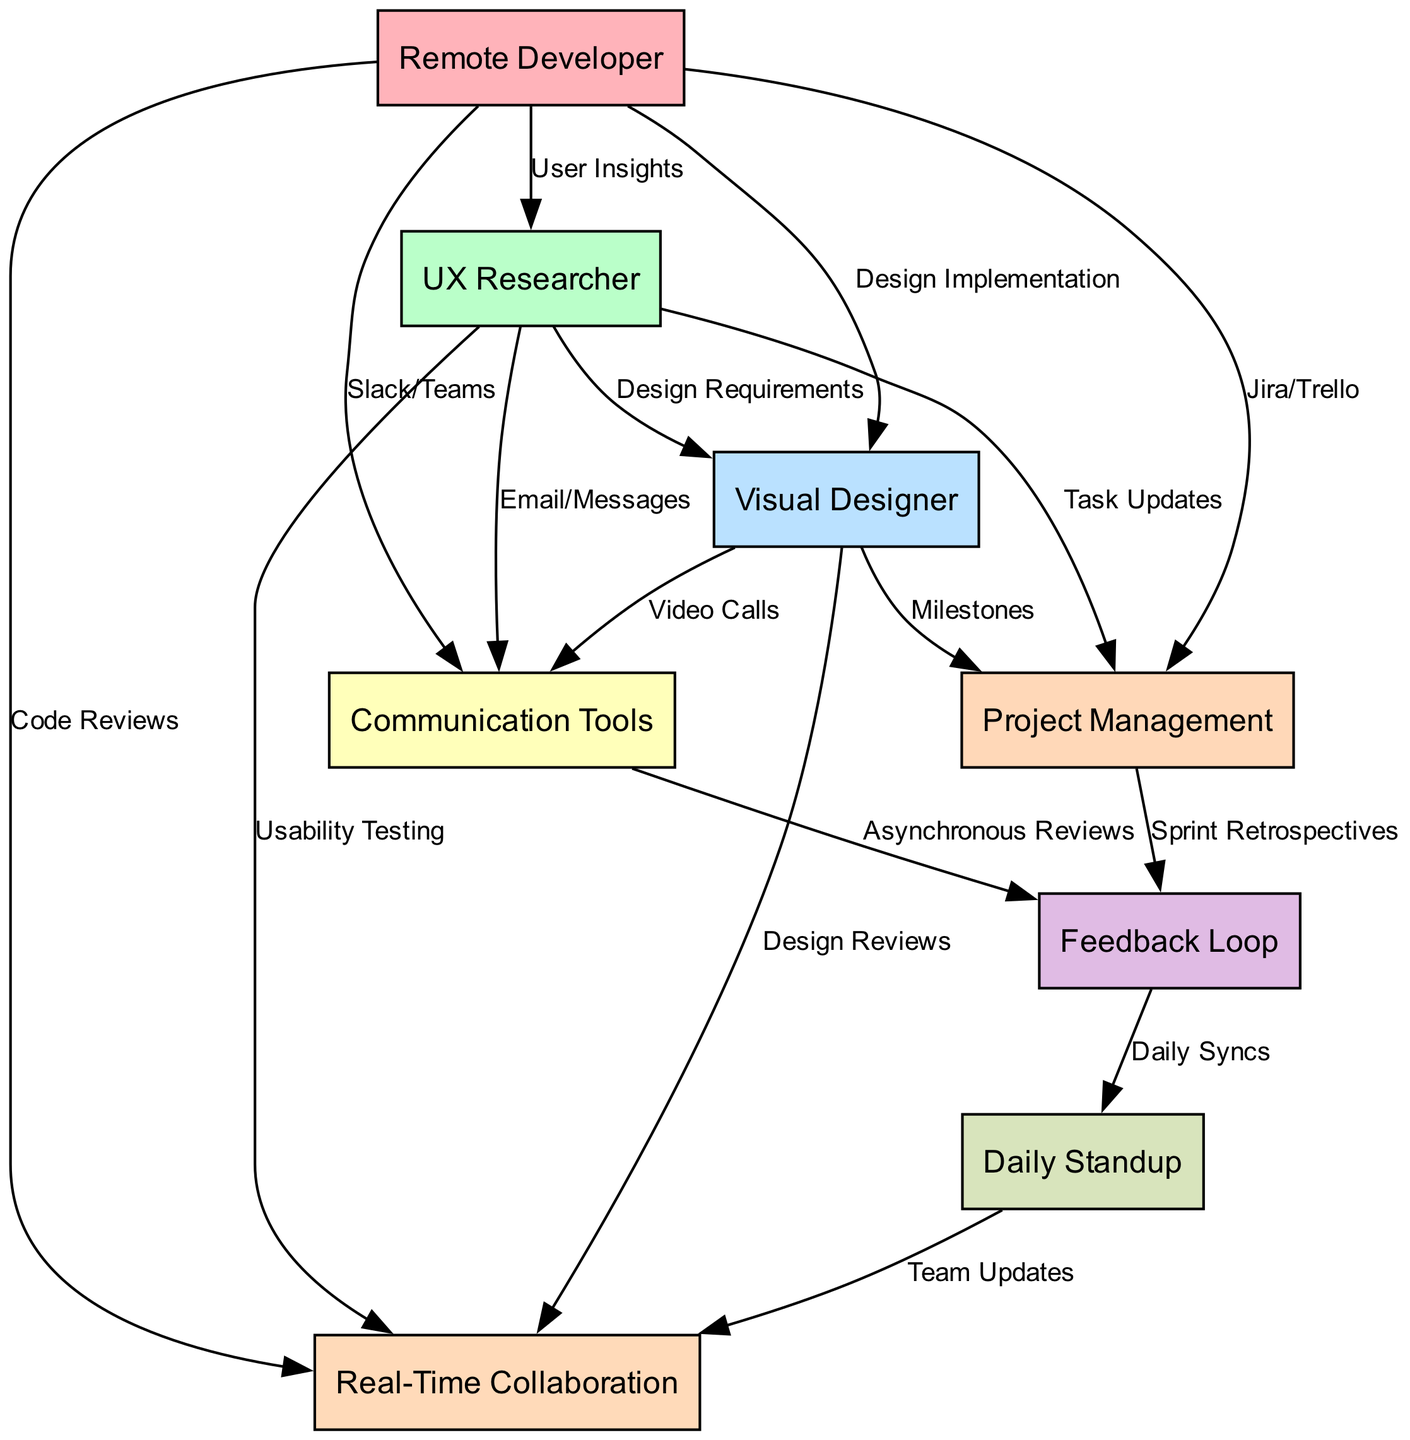What is the total number of nodes in the diagram? The diagram contains 8 distinct nodes: Remote Developer, UX Researcher, Visual Designer, Communication Tools, Project Management, Feedback Loop, Daily Standup, and Real-Time Collaboration.
Answer: 8 Which communication tool is used by the remote developer? The edge from the Remote Developer node to the Communication Tools node indicates that the remote developer uses Slack/Teams for communication.
Answer: Slack/Teams How does the UX Researcher provide information to the Visual Designer? The relationship between the UX Researcher and the Visual Designer is through the edge labeled "Design Requirements," showing that the UX Researcher provides design specifications to the Visual Designer.
Answer: Design Requirements What type of feedback is collected from the Communication Tools? The edge from the Communication Tools node to the Feedback Loop node shows that asynchronous reviews are the type of feedback collected from the communication tools used.
Answer: Asynchronous Reviews Which node receives input from both the Project Management and Communication Tools nodes? The Feedback Loop node has edges coming from both the Project Management and Communication Tools nodes, indicating it receives input from these two sources.
Answer: Feedback Loop How many methods contribute to Real-Time Collaboration? The diagram shows three edges going into the Real-Time Collaboration node from the Daily Standup, Remote Developer, and UX Researcher nodes, indicating three methods contribute to this collaboration.
Answer: 3 What is the role of the Daily Standup in this communication flow? The Daily Standup node is represented by an edge leading to the Collaboration node labeled "Team Updates," indicating its role in facilitating team updates that contribute to collaboration.
Answer: Team Updates Identify a direct connection from the Remote Developer to Project Management. There is a direct edge labeled "Jira/Trello" connecting the Remote Developer node to the Project Management node, representing the developer's use of project management tools.
Answer: Jira/Trello 